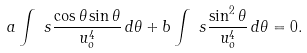<formula> <loc_0><loc_0><loc_500><loc_500>a \int _ { \ } s \frac { \cos \theta \sin \theta } { u _ { o } ^ { 4 } } \, d \theta + b \int _ { \ } s \frac { \sin ^ { 2 } \theta } { u _ { o } ^ { 4 } } \, d \theta = 0 .</formula> 